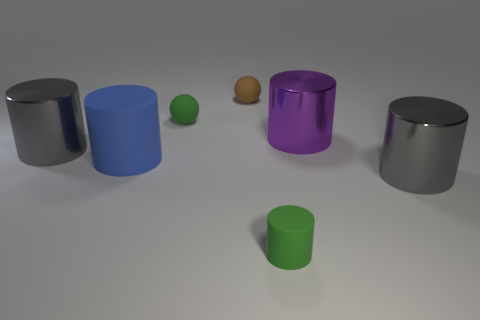Subtract all big purple metallic cylinders. How many cylinders are left? 4 Subtract all gray cylinders. How many cylinders are left? 3 Add 2 small matte spheres. How many objects exist? 9 Add 4 small green balls. How many small green balls exist? 5 Subtract 1 brown spheres. How many objects are left? 6 Subtract all cylinders. How many objects are left? 2 Subtract 1 balls. How many balls are left? 1 Subtract all green balls. Subtract all cyan cubes. How many balls are left? 1 Subtract all brown cylinders. How many brown balls are left? 1 Subtract all green rubber spheres. Subtract all gray metal cylinders. How many objects are left? 4 